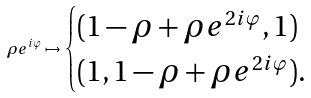Convert formula to latex. <formula><loc_0><loc_0><loc_500><loc_500>\rho e ^ { i \varphi } \mapsto \begin{cases} ( 1 - \rho + \rho e ^ { 2 i \varphi } , 1 ) \\ ( 1 , 1 - \rho + \rho e ^ { 2 i \varphi } ) . \end{cases}</formula> 